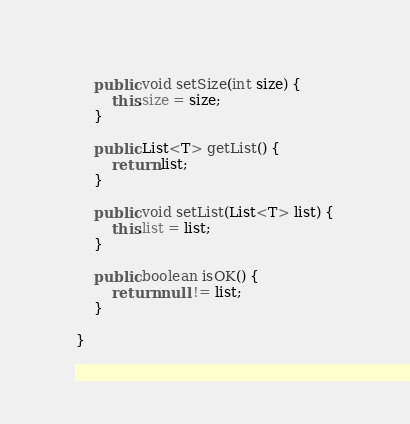Convert code to text. <code><loc_0><loc_0><loc_500><loc_500><_Java_>    public void setSize(int size) {
        this.size = size;
    }

    public List<T> getList() {
        return list;
    }

    public void setList(List<T> list) {
        this.list = list;
    }

    public boolean isOK() {
        return null != list;
    }

}
</code> 